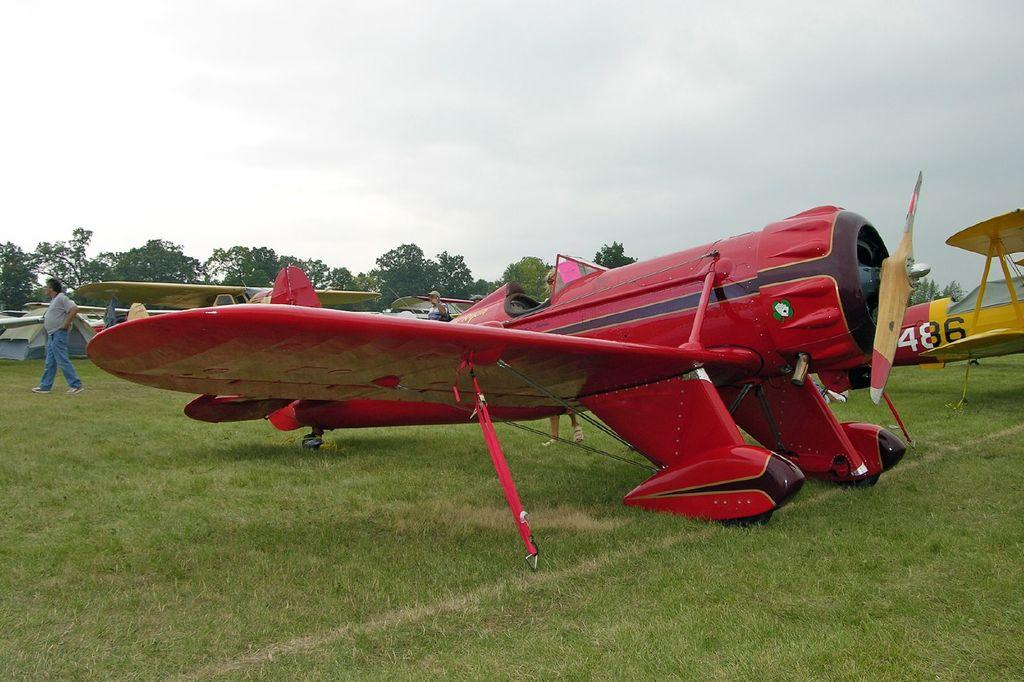<image>
Offer a succinct explanation of the picture presented. Two planes are parked on a grassy terrain with one on the right having the number 486 on its body. 